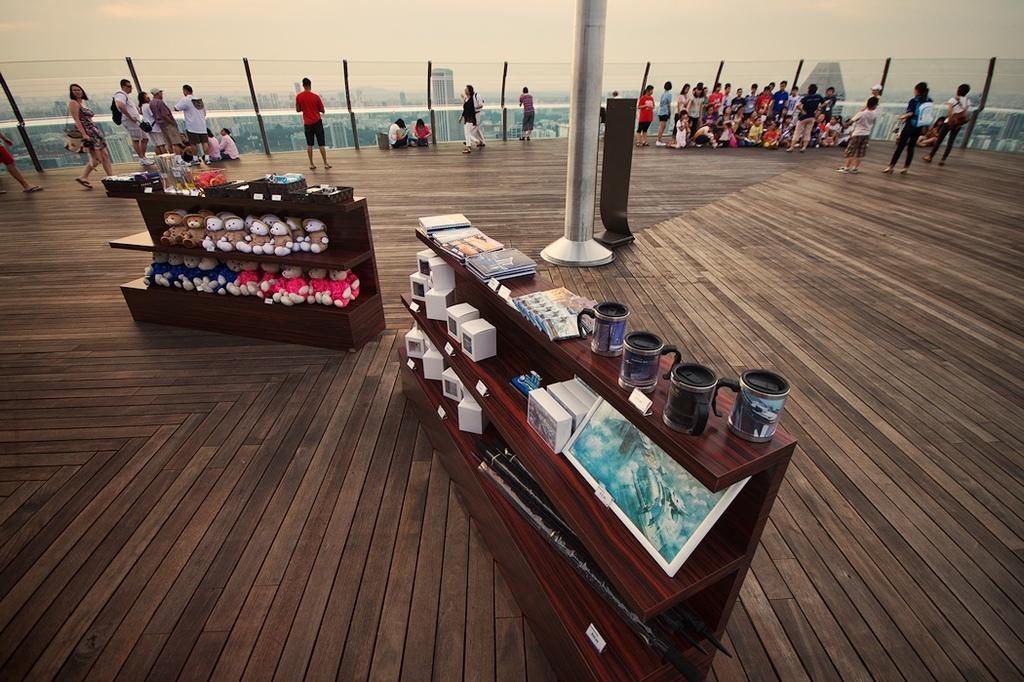How would you summarize this image in a sentence or two? In the picture we can find a wooden floor and group of people standing and sitting and we can find two desks, in one desk we can find dolls and somethings another desk we can find boxes and cups, and we can also find the sky, railing, and some buildings. 